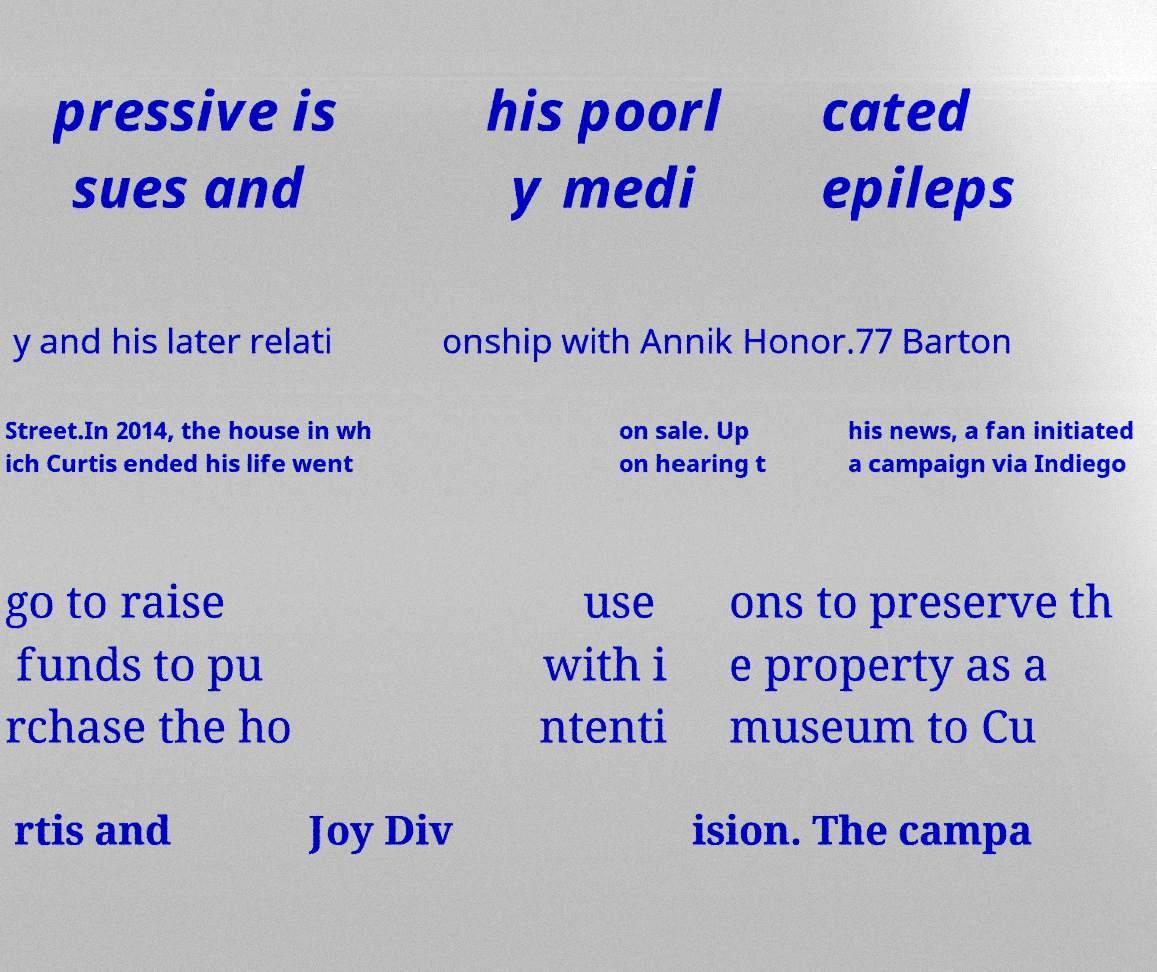What messages or text are displayed in this image? I need them in a readable, typed format. pressive is sues and his poorl y medi cated epileps y and his later relati onship with Annik Honor.77 Barton Street.In 2014, the house in wh ich Curtis ended his life went on sale. Up on hearing t his news, a fan initiated a campaign via Indiego go to raise funds to pu rchase the ho use with i ntenti ons to preserve th e property as a museum to Cu rtis and Joy Div ision. The campa 